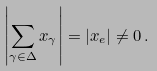Convert formula to latex. <formula><loc_0><loc_0><loc_500><loc_500>\left | \sum _ { \gamma \in \Delta } x _ { \gamma } \right | = | x _ { e } | \neq 0 \, .</formula> 